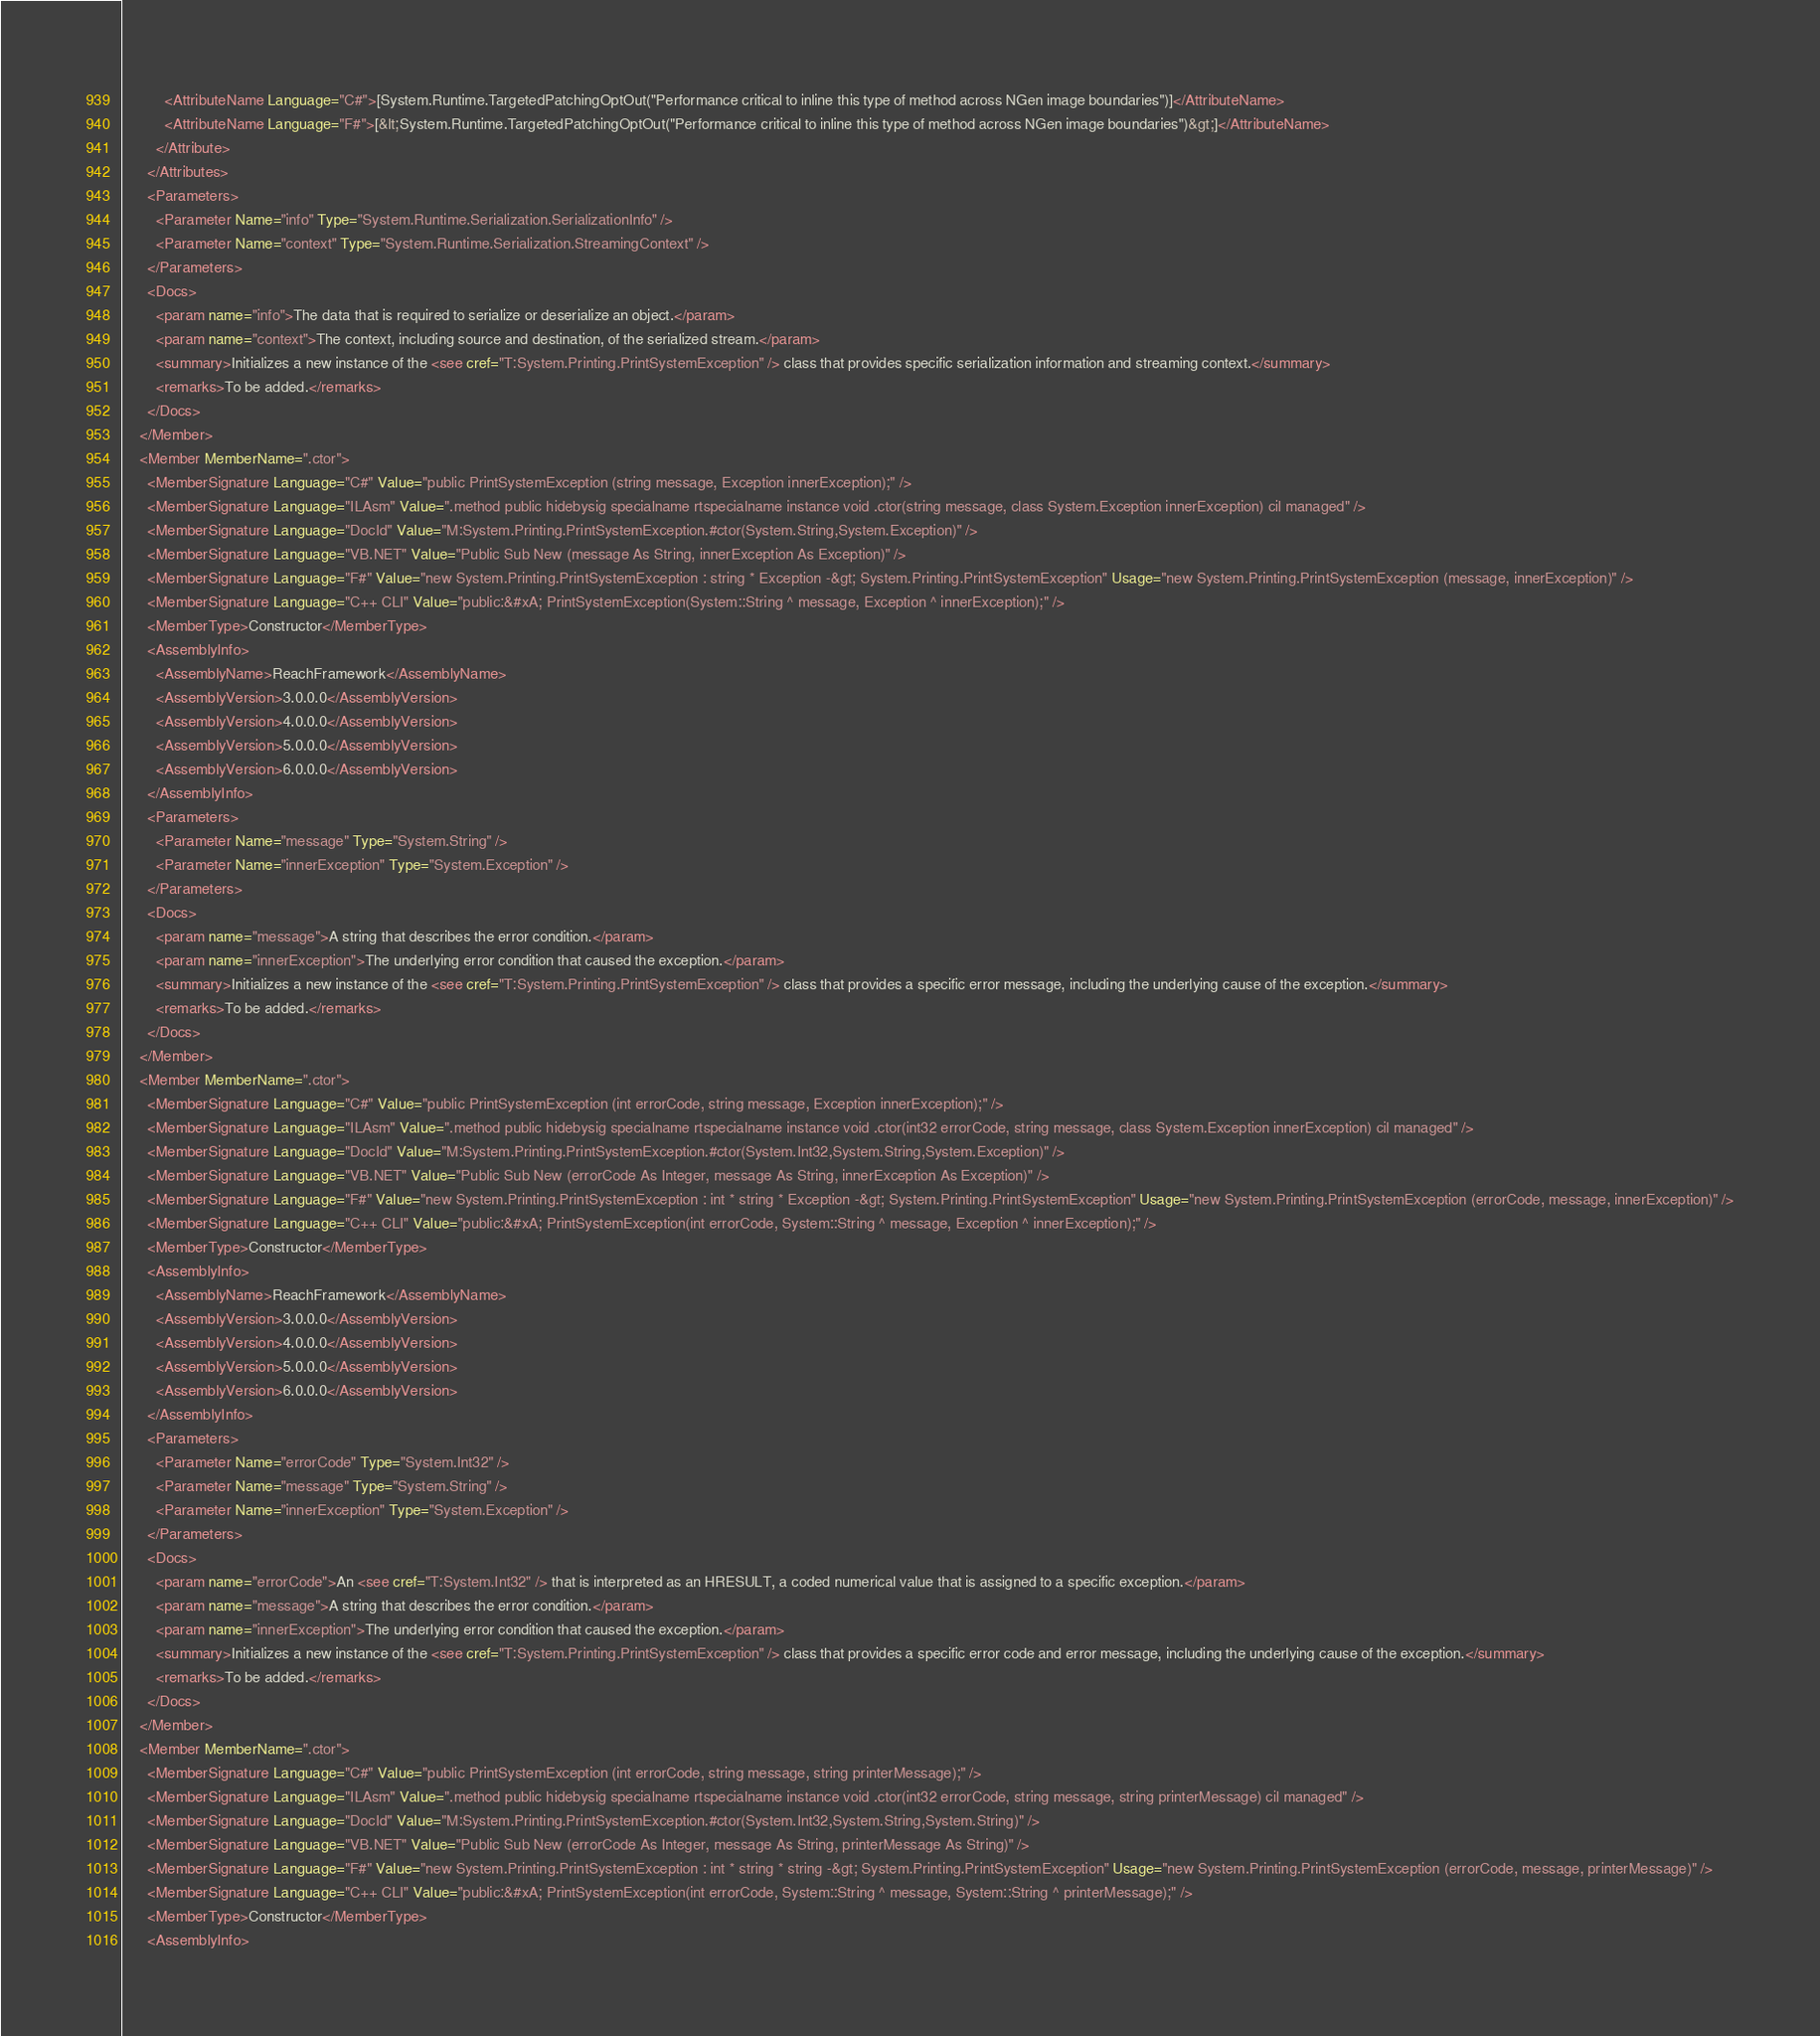<code> <loc_0><loc_0><loc_500><loc_500><_XML_>          <AttributeName Language="C#">[System.Runtime.TargetedPatchingOptOut("Performance critical to inline this type of method across NGen image boundaries")]</AttributeName>
          <AttributeName Language="F#">[&lt;System.Runtime.TargetedPatchingOptOut("Performance critical to inline this type of method across NGen image boundaries")&gt;]</AttributeName>
        </Attribute>
      </Attributes>
      <Parameters>
        <Parameter Name="info" Type="System.Runtime.Serialization.SerializationInfo" />
        <Parameter Name="context" Type="System.Runtime.Serialization.StreamingContext" />
      </Parameters>
      <Docs>
        <param name="info">The data that is required to serialize or deserialize an object.</param>
        <param name="context">The context, including source and destination, of the serialized stream.</param>
        <summary>Initializes a new instance of the <see cref="T:System.Printing.PrintSystemException" /> class that provides specific serialization information and streaming context.</summary>
        <remarks>To be added.</remarks>
      </Docs>
    </Member>
    <Member MemberName=".ctor">
      <MemberSignature Language="C#" Value="public PrintSystemException (string message, Exception innerException);" />
      <MemberSignature Language="ILAsm" Value=".method public hidebysig specialname rtspecialname instance void .ctor(string message, class System.Exception innerException) cil managed" />
      <MemberSignature Language="DocId" Value="M:System.Printing.PrintSystemException.#ctor(System.String,System.Exception)" />
      <MemberSignature Language="VB.NET" Value="Public Sub New (message As String, innerException As Exception)" />
      <MemberSignature Language="F#" Value="new System.Printing.PrintSystemException : string * Exception -&gt; System.Printing.PrintSystemException" Usage="new System.Printing.PrintSystemException (message, innerException)" />
      <MemberSignature Language="C++ CLI" Value="public:&#xA; PrintSystemException(System::String ^ message, Exception ^ innerException);" />
      <MemberType>Constructor</MemberType>
      <AssemblyInfo>
        <AssemblyName>ReachFramework</AssemblyName>
        <AssemblyVersion>3.0.0.0</AssemblyVersion>
        <AssemblyVersion>4.0.0.0</AssemblyVersion>
        <AssemblyVersion>5.0.0.0</AssemblyVersion>
        <AssemblyVersion>6.0.0.0</AssemblyVersion>
      </AssemblyInfo>
      <Parameters>
        <Parameter Name="message" Type="System.String" />
        <Parameter Name="innerException" Type="System.Exception" />
      </Parameters>
      <Docs>
        <param name="message">A string that describes the error condition.</param>
        <param name="innerException">The underlying error condition that caused the exception.</param>
        <summary>Initializes a new instance of the <see cref="T:System.Printing.PrintSystemException" /> class that provides a specific error message, including the underlying cause of the exception.</summary>
        <remarks>To be added.</remarks>
      </Docs>
    </Member>
    <Member MemberName=".ctor">
      <MemberSignature Language="C#" Value="public PrintSystemException (int errorCode, string message, Exception innerException);" />
      <MemberSignature Language="ILAsm" Value=".method public hidebysig specialname rtspecialname instance void .ctor(int32 errorCode, string message, class System.Exception innerException) cil managed" />
      <MemberSignature Language="DocId" Value="M:System.Printing.PrintSystemException.#ctor(System.Int32,System.String,System.Exception)" />
      <MemberSignature Language="VB.NET" Value="Public Sub New (errorCode As Integer, message As String, innerException As Exception)" />
      <MemberSignature Language="F#" Value="new System.Printing.PrintSystemException : int * string * Exception -&gt; System.Printing.PrintSystemException" Usage="new System.Printing.PrintSystemException (errorCode, message, innerException)" />
      <MemberSignature Language="C++ CLI" Value="public:&#xA; PrintSystemException(int errorCode, System::String ^ message, Exception ^ innerException);" />
      <MemberType>Constructor</MemberType>
      <AssemblyInfo>
        <AssemblyName>ReachFramework</AssemblyName>
        <AssemblyVersion>3.0.0.0</AssemblyVersion>
        <AssemblyVersion>4.0.0.0</AssemblyVersion>
        <AssemblyVersion>5.0.0.0</AssemblyVersion>
        <AssemblyVersion>6.0.0.0</AssemblyVersion>
      </AssemblyInfo>
      <Parameters>
        <Parameter Name="errorCode" Type="System.Int32" />
        <Parameter Name="message" Type="System.String" />
        <Parameter Name="innerException" Type="System.Exception" />
      </Parameters>
      <Docs>
        <param name="errorCode">An <see cref="T:System.Int32" /> that is interpreted as an HRESULT, a coded numerical value that is assigned to a specific exception.</param>
        <param name="message">A string that describes the error condition.</param>
        <param name="innerException">The underlying error condition that caused the exception.</param>
        <summary>Initializes a new instance of the <see cref="T:System.Printing.PrintSystemException" /> class that provides a specific error code and error message, including the underlying cause of the exception.</summary>
        <remarks>To be added.</remarks>
      </Docs>
    </Member>
    <Member MemberName=".ctor">
      <MemberSignature Language="C#" Value="public PrintSystemException (int errorCode, string message, string printerMessage);" />
      <MemberSignature Language="ILAsm" Value=".method public hidebysig specialname rtspecialname instance void .ctor(int32 errorCode, string message, string printerMessage) cil managed" />
      <MemberSignature Language="DocId" Value="M:System.Printing.PrintSystemException.#ctor(System.Int32,System.String,System.String)" />
      <MemberSignature Language="VB.NET" Value="Public Sub New (errorCode As Integer, message As String, printerMessage As String)" />
      <MemberSignature Language="F#" Value="new System.Printing.PrintSystemException : int * string * string -&gt; System.Printing.PrintSystemException" Usage="new System.Printing.PrintSystemException (errorCode, message, printerMessage)" />
      <MemberSignature Language="C++ CLI" Value="public:&#xA; PrintSystemException(int errorCode, System::String ^ message, System::String ^ printerMessage);" />
      <MemberType>Constructor</MemberType>
      <AssemblyInfo></code> 